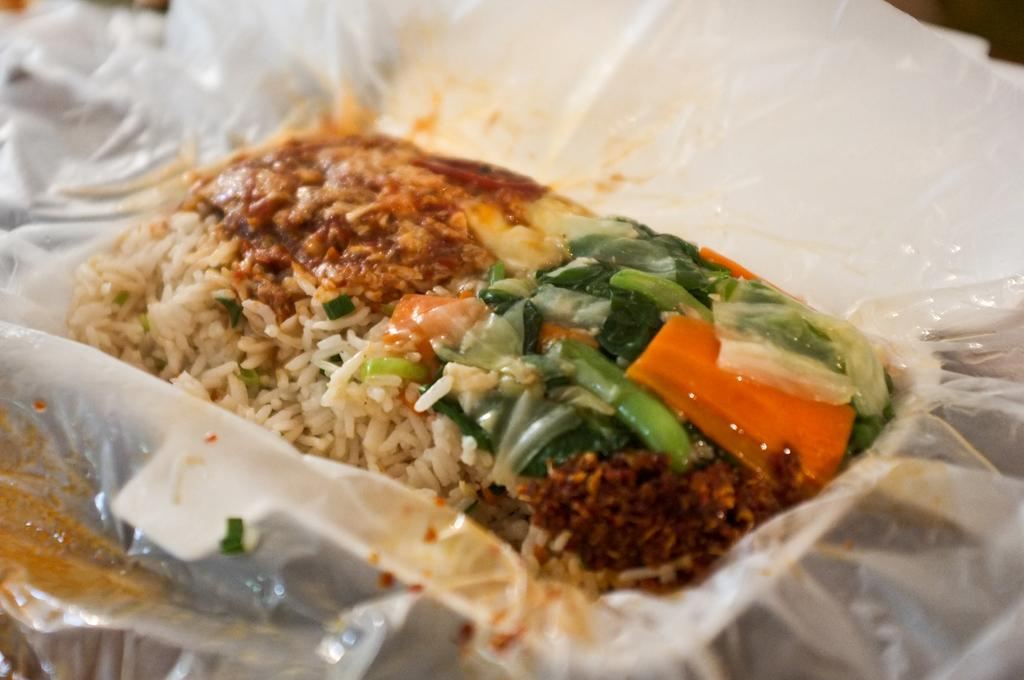What type of food can be seen in the image? There is rice and a vegetable salad in the image. What is the food item contained in the bowl? The bowl contains a food item, but the specific type is not mentioned in the facts. How is the bowl's content protected? The bowl appears to be covered by a plastic cover. What type of scent is emanating from the plough in the image? There is no plough present in the image, so it is not possible to determine the scent emanating from it. 